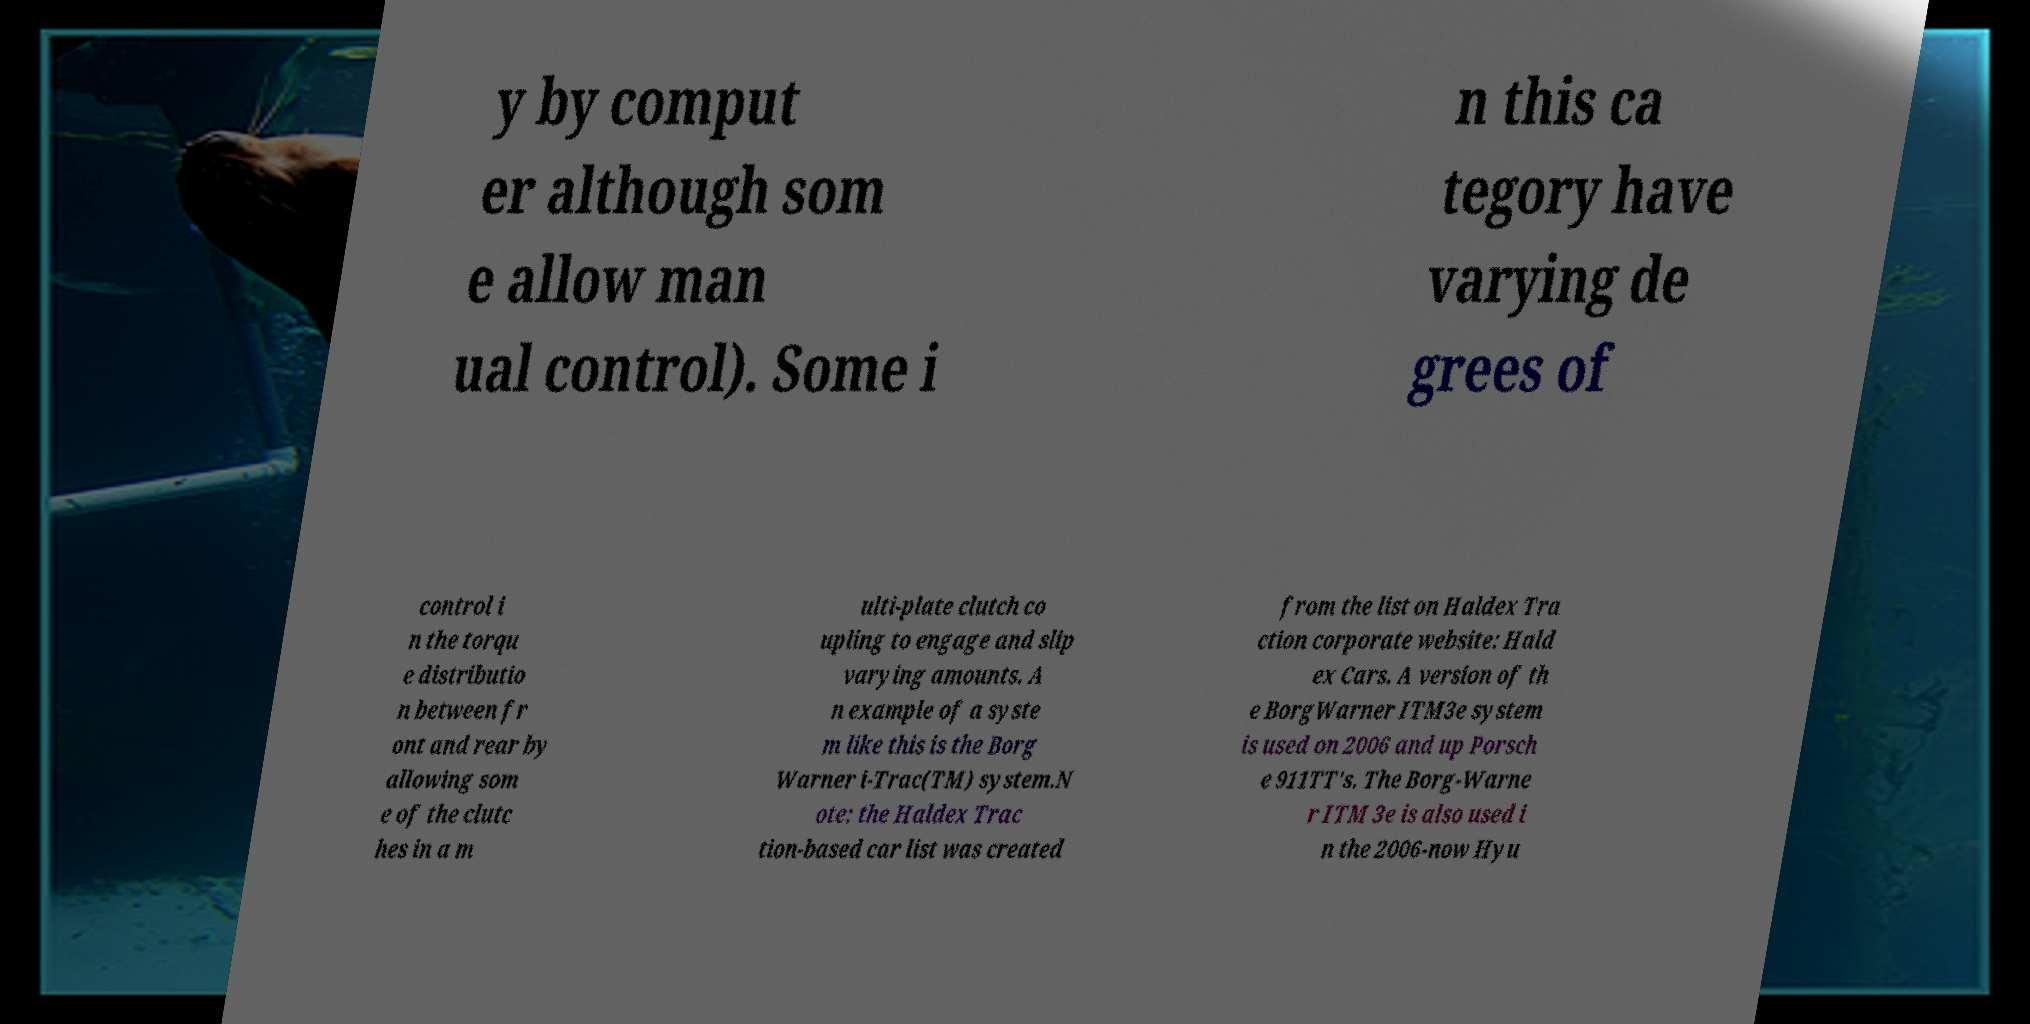Could you assist in decoding the text presented in this image and type it out clearly? y by comput er although som e allow man ual control). Some i n this ca tegory have varying de grees of control i n the torqu e distributio n between fr ont and rear by allowing som e of the clutc hes in a m ulti-plate clutch co upling to engage and slip varying amounts. A n example of a syste m like this is the Borg Warner i-Trac(TM) system.N ote: the Haldex Trac tion-based car list was created from the list on Haldex Tra ction corporate website: Hald ex Cars. A version of th e BorgWarner ITM3e system is used on 2006 and up Porsch e 911TT's. The Borg-Warne r ITM 3e is also used i n the 2006-now Hyu 